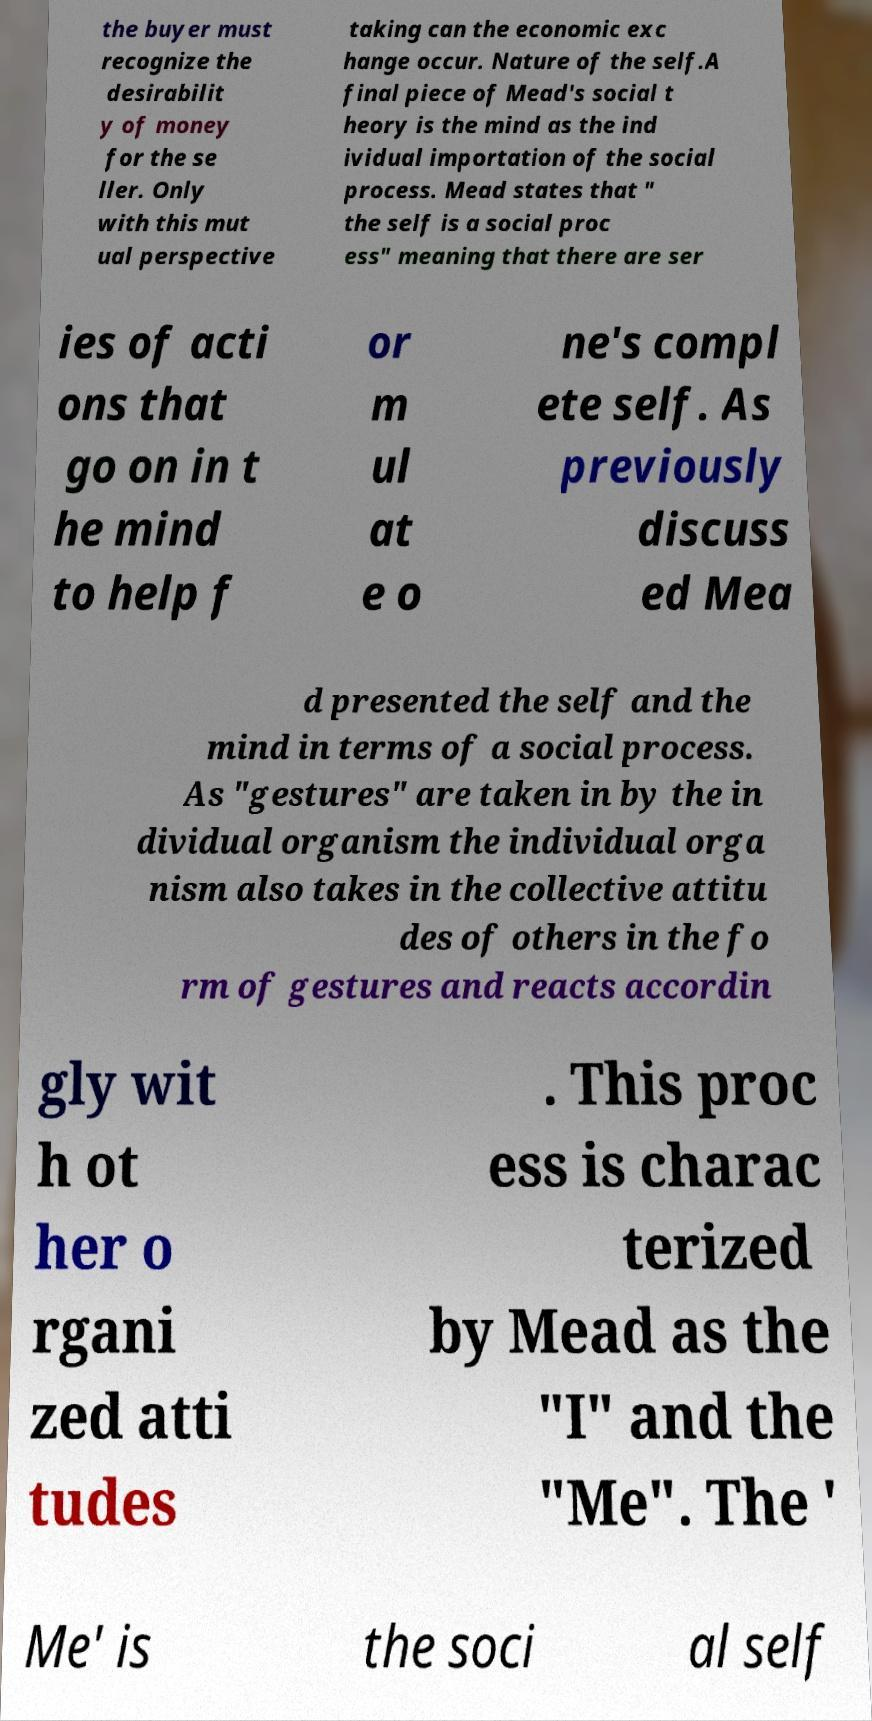There's text embedded in this image that I need extracted. Can you transcribe it verbatim? the buyer must recognize the desirabilit y of money for the se ller. Only with this mut ual perspective taking can the economic exc hange occur. Nature of the self.A final piece of Mead's social t heory is the mind as the ind ividual importation of the social process. Mead states that " the self is a social proc ess" meaning that there are ser ies of acti ons that go on in t he mind to help f or m ul at e o ne's compl ete self. As previously discuss ed Mea d presented the self and the mind in terms of a social process. As "gestures" are taken in by the in dividual organism the individual orga nism also takes in the collective attitu des of others in the fo rm of gestures and reacts accordin gly wit h ot her o rgani zed atti tudes . This proc ess is charac terized by Mead as the "I" and the "Me". The ' Me' is the soci al self 